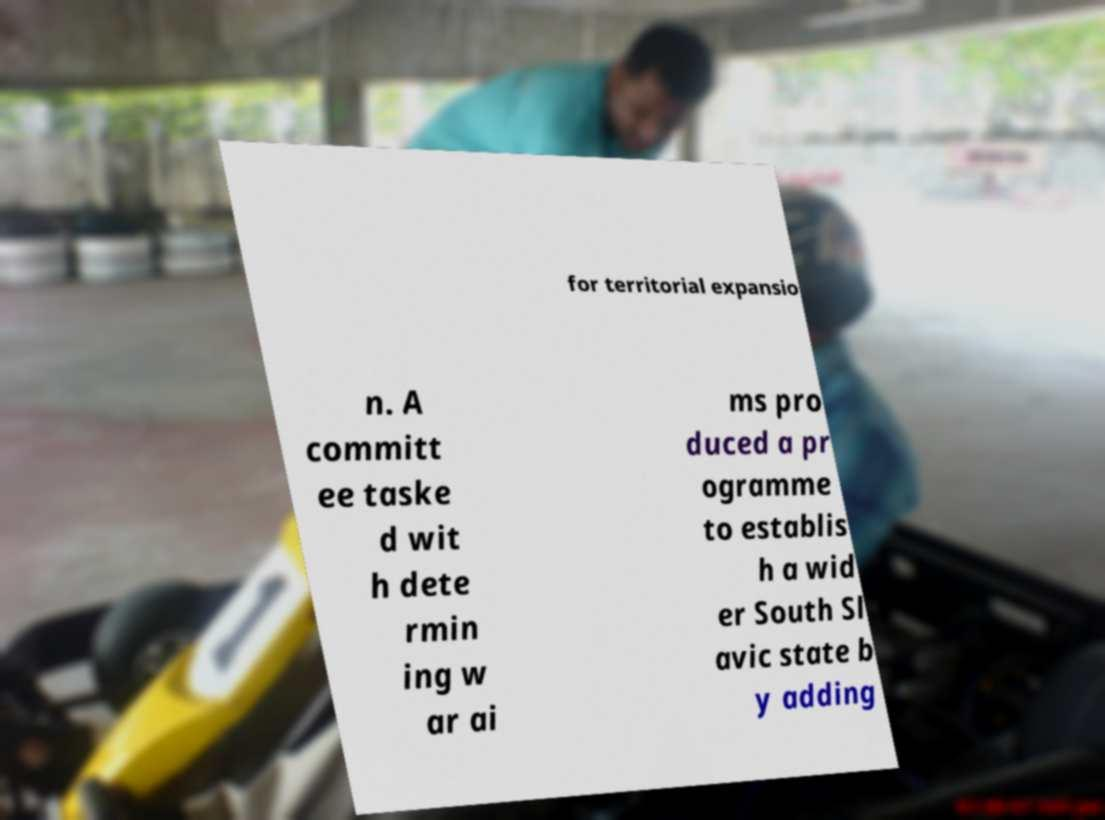There's text embedded in this image that I need extracted. Can you transcribe it verbatim? for territorial expansio n. A committ ee taske d wit h dete rmin ing w ar ai ms pro duced a pr ogramme to establis h a wid er South Sl avic state b y adding 